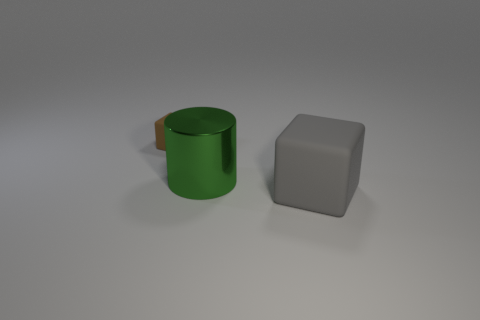Add 3 rubber things. How many objects exist? 6 Subtract all cubes. How many objects are left? 1 Add 2 gray cubes. How many gray cubes are left? 3 Add 2 cylinders. How many cylinders exist? 3 Subtract 1 brown cubes. How many objects are left? 2 Subtract all brown rubber things. Subtract all cubes. How many objects are left? 0 